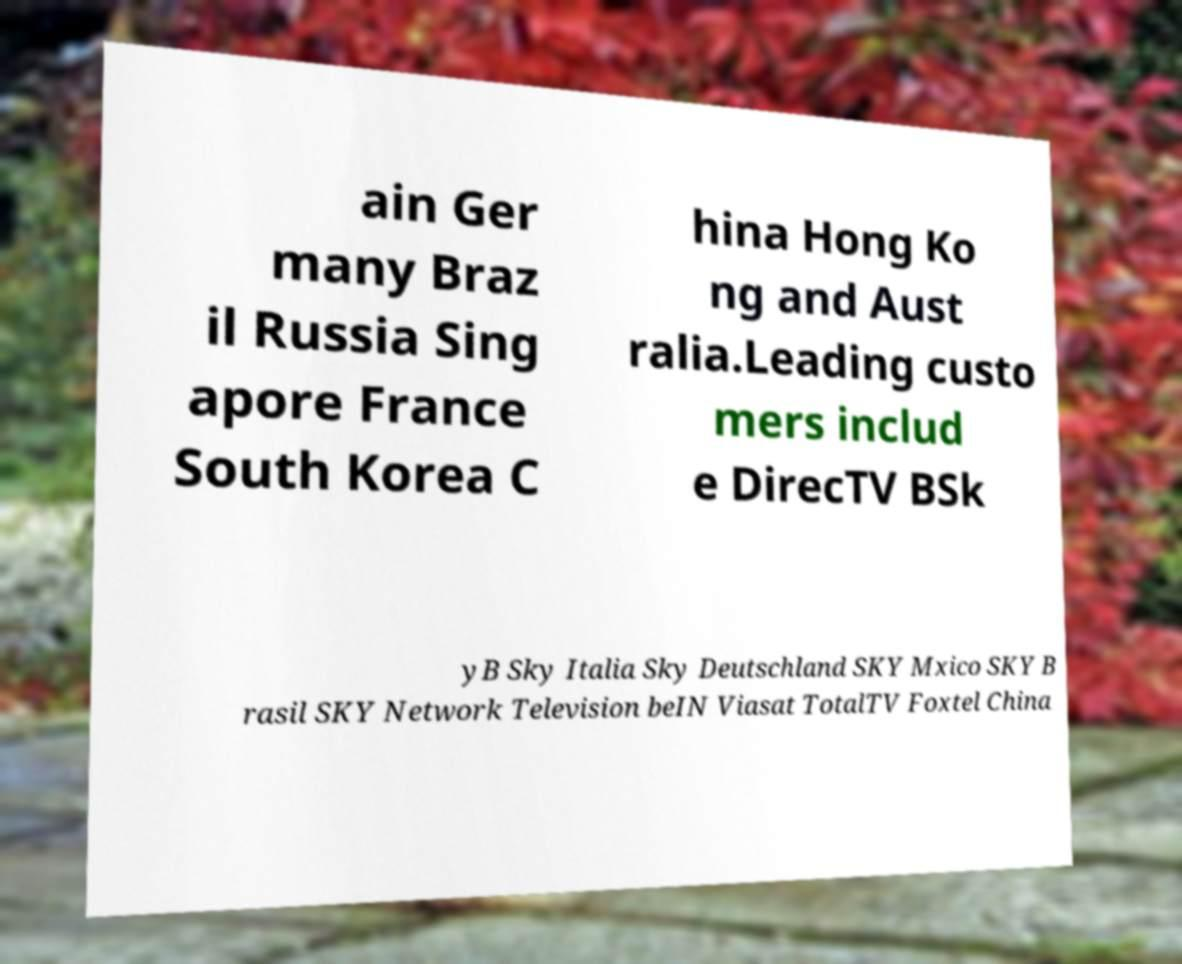There's text embedded in this image that I need extracted. Can you transcribe it verbatim? ain Ger many Braz il Russia Sing apore France South Korea C hina Hong Ko ng and Aust ralia.Leading custo mers includ e DirecTV BSk yB Sky Italia Sky Deutschland SKY Mxico SKY B rasil SKY Network Television beIN Viasat TotalTV Foxtel China 